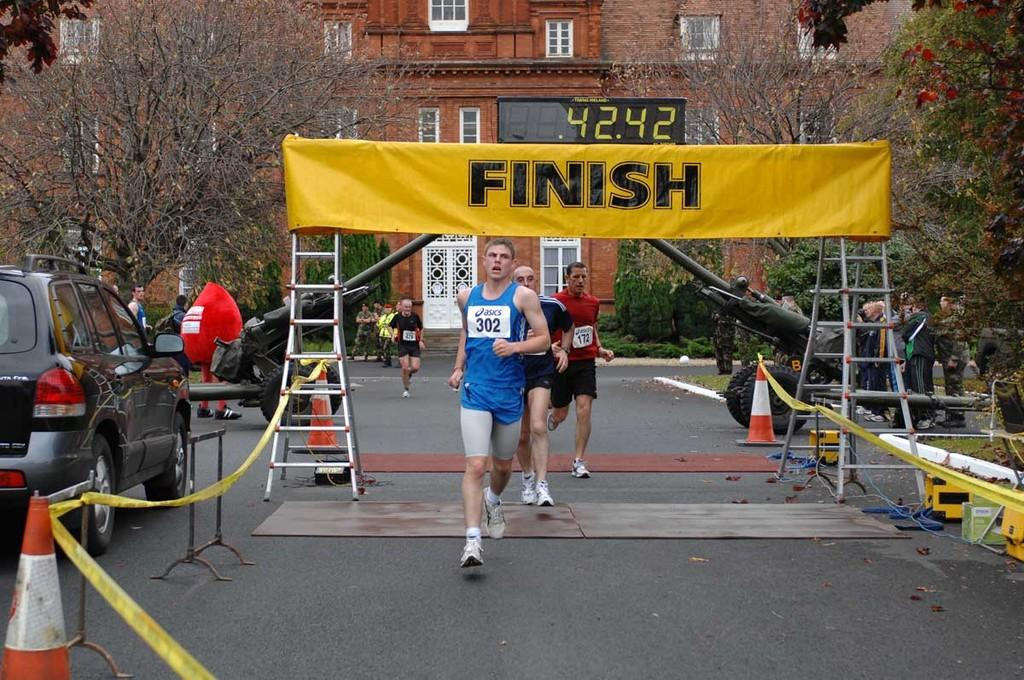<image>
Render a clear and concise summary of the photo. Person running under a yellow FINISH banner with a number 302 on his chest. 